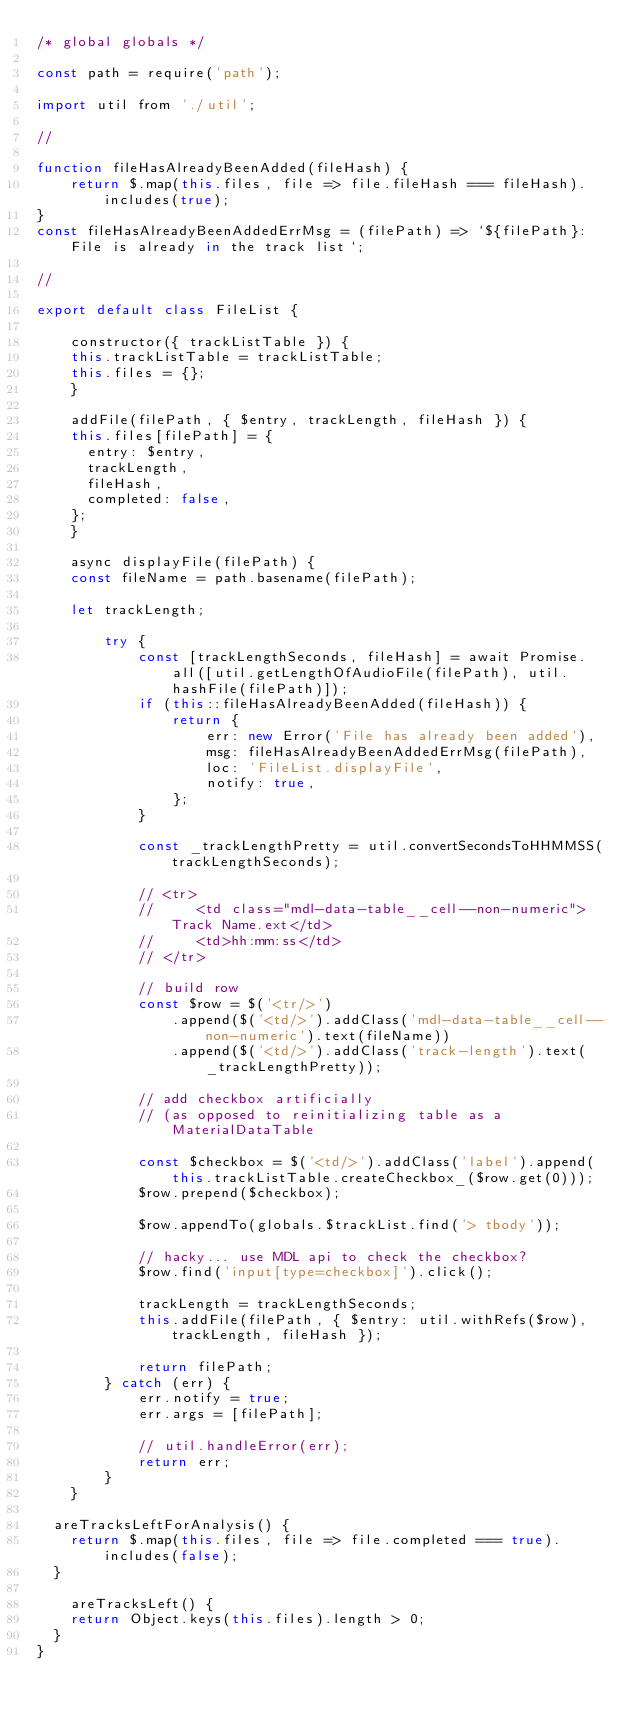Convert code to text. <code><loc_0><loc_0><loc_500><loc_500><_JavaScript_>/* global globals */

const path = require('path');

import util from './util';

//

function fileHasAlreadyBeenAdded(fileHash) {
    return $.map(this.files, file => file.fileHash === fileHash).includes(true);
}
const fileHasAlreadyBeenAddedErrMsg = (filePath) => `${filePath}: File is already in the track list`;

//

export default class FileList {

    constructor({ trackListTable }) {
		this.trackListTable = trackListTable;
		this.files = {};
    }

    addFile(filePath, { $entry, trackLength, fileHash }) {
		this.files[filePath] = {
			entry: $entry,
			trackLength,
			fileHash,
			completed: false,
		};
    }

    async displayFile(filePath) {
		const fileName = path.basename(filePath);

		let trackLength;

        try {
            const [trackLengthSeconds, fileHash] = await Promise.all([util.getLengthOfAudioFile(filePath), util.hashFile(filePath)]);
            if (this::fileHasAlreadyBeenAdded(fileHash)) {
                return {
                    err: new Error('File has already been added'),
                    msg: fileHasAlreadyBeenAddedErrMsg(filePath),
                    loc: 'FileList.displayFile',
                    notify: true,
                };
            }

            const _trackLengthPretty = util.convertSecondsToHHMMSS(trackLengthSeconds);

            // <tr>
            //     <td class="mdl-data-table__cell--non-numeric">Track Name.ext</td>
            //     <td>hh:mm:ss</td>
            // </tr>

            // build row
            const $row = $('<tr/>')
                .append($('<td/>').addClass('mdl-data-table__cell--non-numeric').text(fileName))
                .append($('<td/>').addClass('track-length').text(_trackLengthPretty));

            // add checkbox artificially
            // (as opposed to reinitializing table as a MaterialDataTable

            const $checkbox = $('<td/>').addClass('label').append(this.trackListTable.createCheckbox_($row.get(0)));
            $row.prepend($checkbox);

            $row.appendTo(globals.$trackList.find('> tbody'));

            // hacky... use MDL api to check the checkbox?
            $row.find('input[type=checkbox]').click();

            trackLength = trackLengthSeconds;
            this.addFile(filePath, { $entry: util.withRefs($row), trackLength, fileHash });

            return filePath;
        } catch (err) {
            err.notify = true;
            err.args = [filePath];

            // util.handleError(err);
            return err;
        }
    }

	areTracksLeftForAnalysis() {
		return $.map(this.files, file => file.completed === true).includes(false);
	}

    areTracksLeft() {
		return Object.keys(this.files).length > 0;
	}
}
</code> 